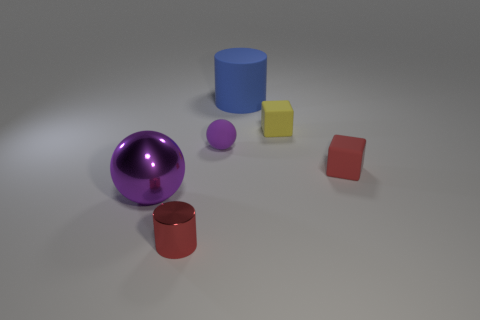There is a big shiny object; is it the same color as the tiny rubber thing that is to the left of the yellow thing?
Ensure brevity in your answer.  Yes. The purple metal object that is the same shape as the small purple matte object is what size?
Keep it short and to the point. Large. There is a object that is both in front of the red rubber thing and behind the red shiny thing; what is its shape?
Ensure brevity in your answer.  Sphere. Does the red cylinder have the same size as the block that is in front of the tiny purple sphere?
Your answer should be very brief. Yes. What is the color of the other object that is the same shape as the tiny purple thing?
Your answer should be compact. Purple. There is a purple thing that is to the right of the shiny ball; does it have the same size as the rubber object to the right of the small yellow thing?
Offer a very short reply. Yes. Do the red shiny thing and the purple rubber object have the same shape?
Provide a short and direct response. No. How many objects are either metallic objects that are on the right side of the purple metal ball or big cyan metal spheres?
Your answer should be compact. 1. Is there a tiny red shiny object of the same shape as the large shiny object?
Ensure brevity in your answer.  No. Are there an equal number of small purple objects that are in front of the large purple metallic sphere and small yellow matte things?
Make the answer very short. No. 